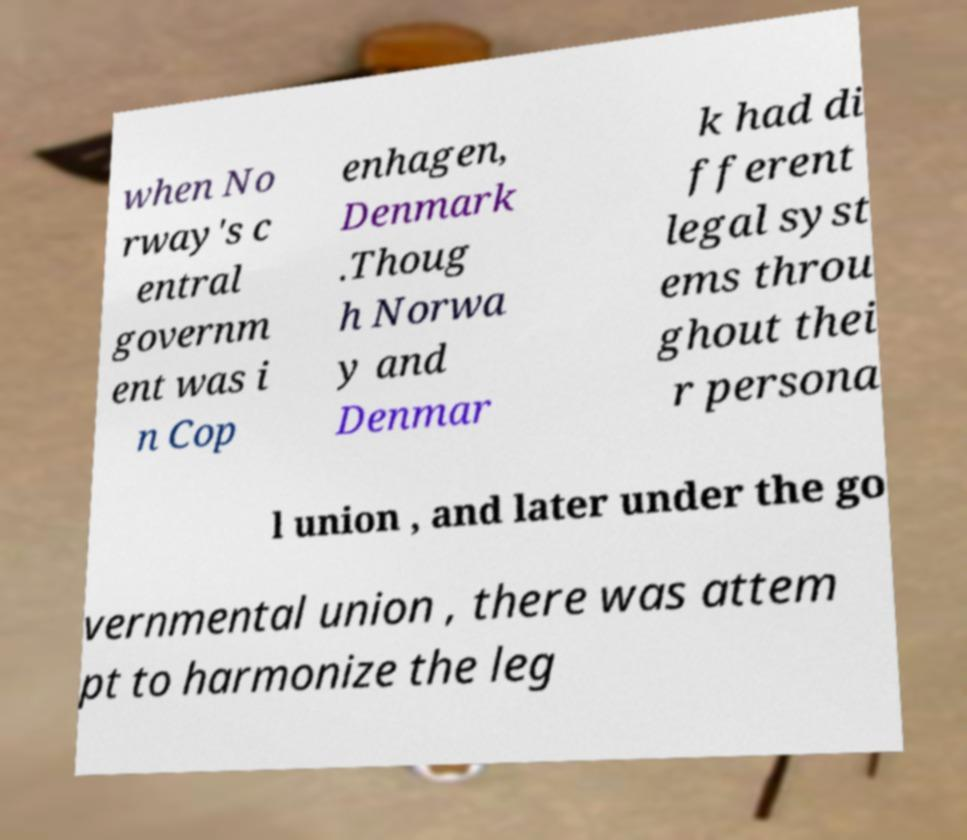Could you extract and type out the text from this image? when No rway's c entral governm ent was i n Cop enhagen, Denmark .Thoug h Norwa y and Denmar k had di fferent legal syst ems throu ghout thei r persona l union , and later under the go vernmental union , there was attem pt to harmonize the leg 